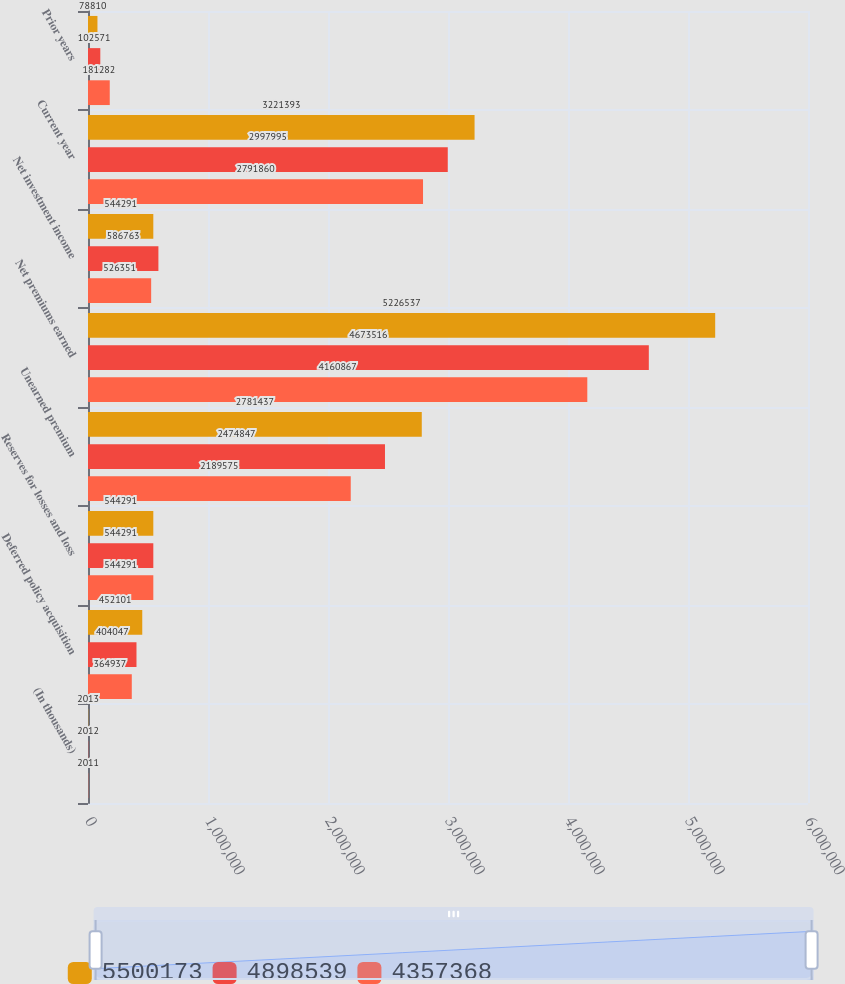<chart> <loc_0><loc_0><loc_500><loc_500><stacked_bar_chart><ecel><fcel>(In thousands)<fcel>Deferred policy acquisition<fcel>Reserves for losses and loss<fcel>Unearned premium<fcel>Net premiums earned<fcel>Net investment income<fcel>Current year<fcel>Prior years<nl><fcel>5.50017e+06<fcel>2013<fcel>452101<fcel>544291<fcel>2.78144e+06<fcel>5.22654e+06<fcel>544291<fcel>3.22139e+06<fcel>78810<nl><fcel>4.89854e+06<fcel>2012<fcel>404047<fcel>544291<fcel>2.47485e+06<fcel>4.67352e+06<fcel>586763<fcel>2.998e+06<fcel>102571<nl><fcel>4.35737e+06<fcel>2011<fcel>364937<fcel>544291<fcel>2.18958e+06<fcel>4.16087e+06<fcel>526351<fcel>2.79186e+06<fcel>181282<nl></chart> 